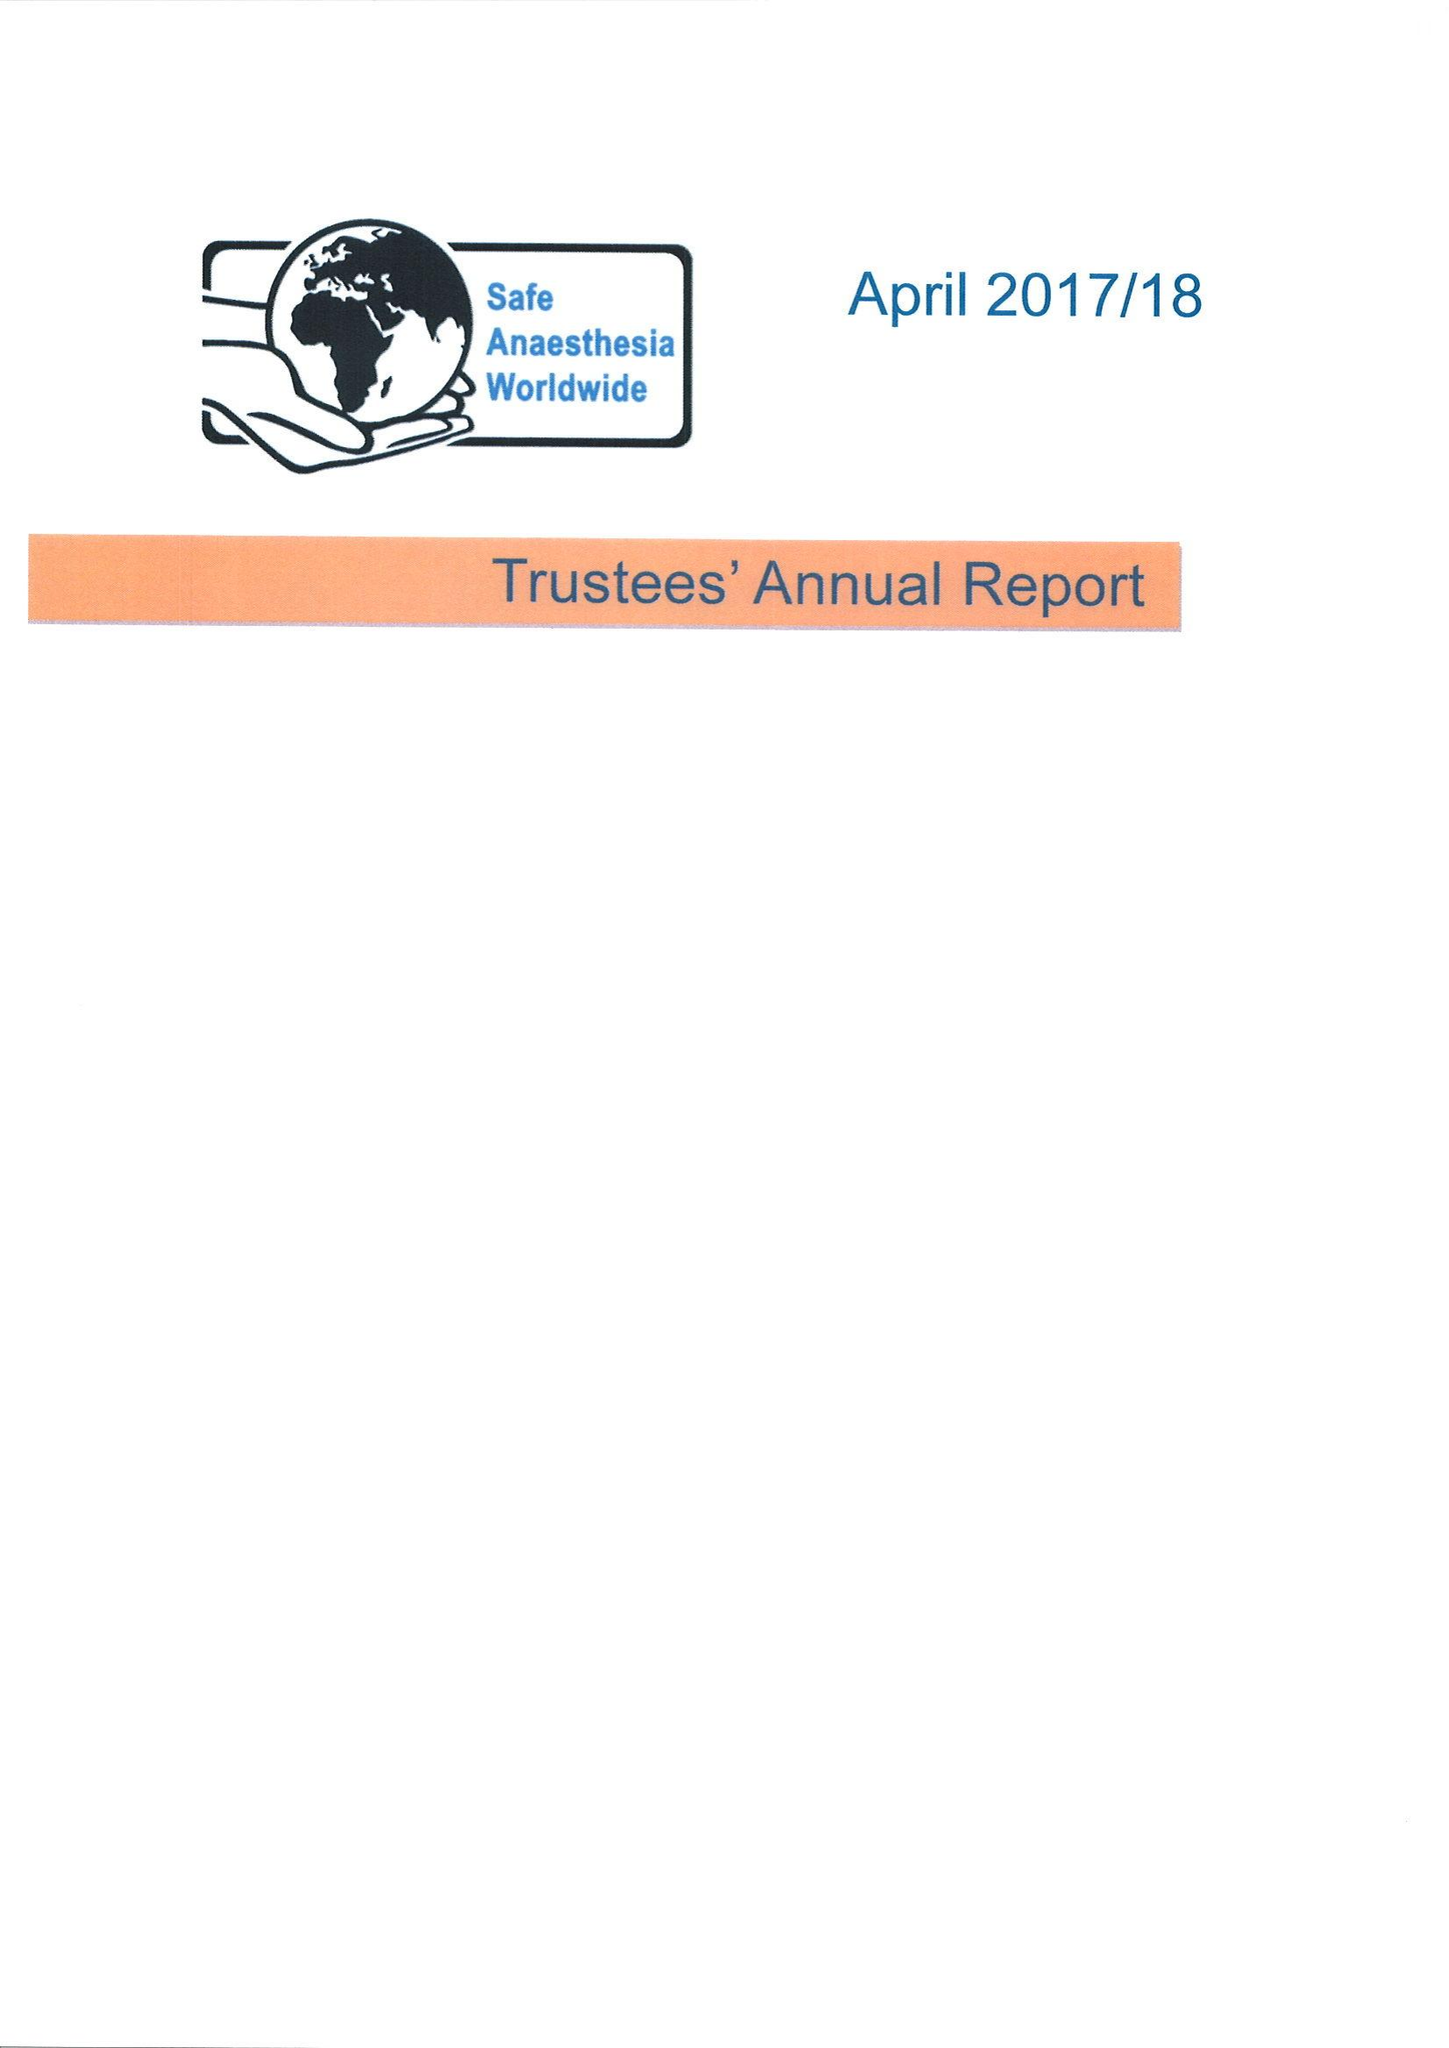What is the value for the report_date?
Answer the question using a single word or phrase. 2018-04-05 